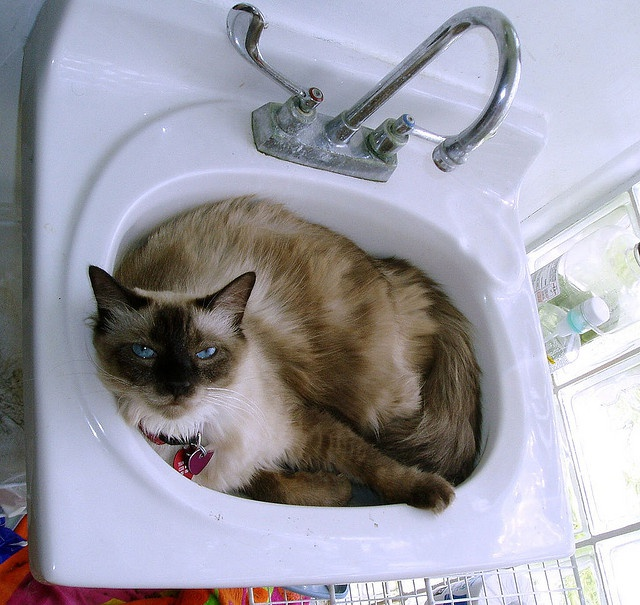Describe the objects in this image and their specific colors. I can see sink in gray, lavender, and darkgray tones, cat in gray, black, and darkgray tones, bottle in gray, white, darkgray, and lightgray tones, and bottle in gray, lightgray, lightblue, and darkgray tones in this image. 